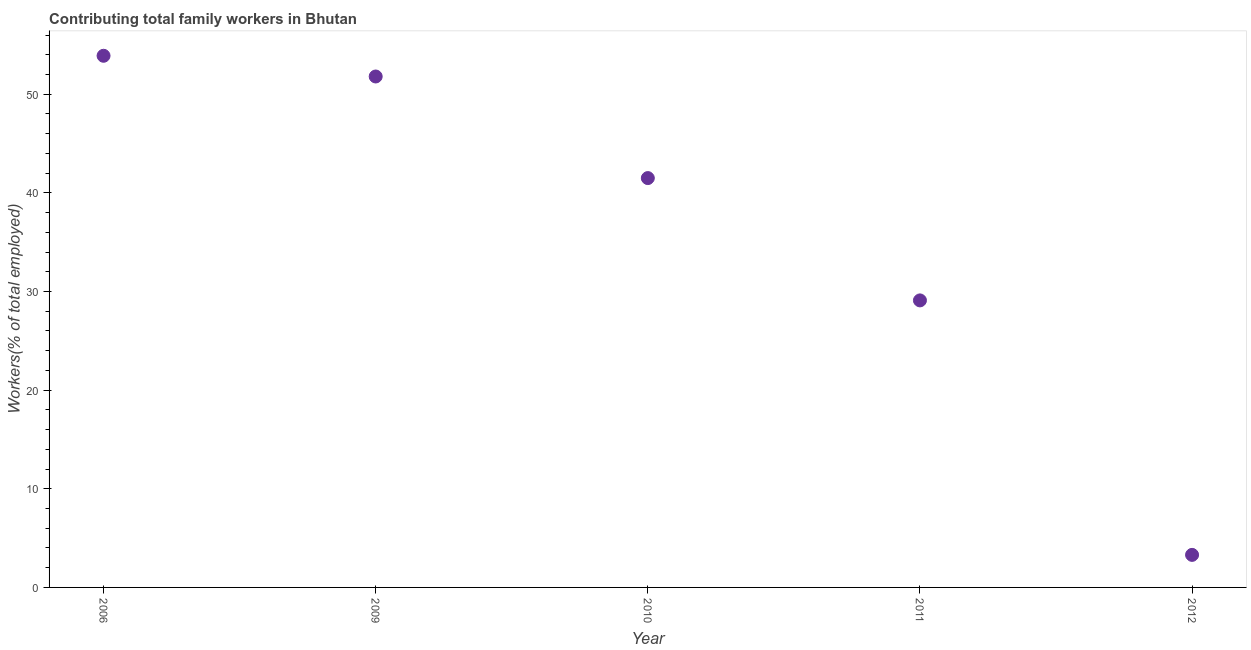What is the contributing family workers in 2012?
Give a very brief answer. 3.3. Across all years, what is the maximum contributing family workers?
Your answer should be compact. 53.9. Across all years, what is the minimum contributing family workers?
Make the answer very short. 3.3. In which year was the contributing family workers maximum?
Your answer should be compact. 2006. In which year was the contributing family workers minimum?
Your answer should be compact. 2012. What is the sum of the contributing family workers?
Make the answer very short. 179.6. What is the difference between the contributing family workers in 2010 and 2012?
Offer a terse response. 38.2. What is the average contributing family workers per year?
Your answer should be compact. 35.92. What is the median contributing family workers?
Your answer should be compact. 41.5. In how many years, is the contributing family workers greater than 6 %?
Keep it short and to the point. 4. What is the ratio of the contributing family workers in 2006 to that in 2009?
Keep it short and to the point. 1.04. Is the contributing family workers in 2006 less than that in 2009?
Keep it short and to the point. No. Is the difference between the contributing family workers in 2009 and 2012 greater than the difference between any two years?
Keep it short and to the point. No. What is the difference between the highest and the second highest contributing family workers?
Keep it short and to the point. 2.1. Is the sum of the contributing family workers in 2006 and 2011 greater than the maximum contributing family workers across all years?
Give a very brief answer. Yes. What is the difference between the highest and the lowest contributing family workers?
Offer a very short reply. 50.6. How many years are there in the graph?
Provide a short and direct response. 5. What is the difference between two consecutive major ticks on the Y-axis?
Keep it short and to the point. 10. Does the graph contain grids?
Make the answer very short. No. What is the title of the graph?
Provide a succinct answer. Contributing total family workers in Bhutan. What is the label or title of the Y-axis?
Offer a very short reply. Workers(% of total employed). What is the Workers(% of total employed) in 2006?
Your response must be concise. 53.9. What is the Workers(% of total employed) in 2009?
Your answer should be compact. 51.8. What is the Workers(% of total employed) in 2010?
Your answer should be compact. 41.5. What is the Workers(% of total employed) in 2011?
Provide a succinct answer. 29.1. What is the Workers(% of total employed) in 2012?
Your answer should be very brief. 3.3. What is the difference between the Workers(% of total employed) in 2006 and 2009?
Provide a succinct answer. 2.1. What is the difference between the Workers(% of total employed) in 2006 and 2011?
Ensure brevity in your answer.  24.8. What is the difference between the Workers(% of total employed) in 2006 and 2012?
Your answer should be compact. 50.6. What is the difference between the Workers(% of total employed) in 2009 and 2011?
Your response must be concise. 22.7. What is the difference between the Workers(% of total employed) in 2009 and 2012?
Provide a succinct answer. 48.5. What is the difference between the Workers(% of total employed) in 2010 and 2011?
Ensure brevity in your answer.  12.4. What is the difference between the Workers(% of total employed) in 2010 and 2012?
Offer a terse response. 38.2. What is the difference between the Workers(% of total employed) in 2011 and 2012?
Your answer should be compact. 25.8. What is the ratio of the Workers(% of total employed) in 2006 to that in 2009?
Ensure brevity in your answer.  1.04. What is the ratio of the Workers(% of total employed) in 2006 to that in 2010?
Provide a succinct answer. 1.3. What is the ratio of the Workers(% of total employed) in 2006 to that in 2011?
Provide a succinct answer. 1.85. What is the ratio of the Workers(% of total employed) in 2006 to that in 2012?
Provide a succinct answer. 16.33. What is the ratio of the Workers(% of total employed) in 2009 to that in 2010?
Ensure brevity in your answer.  1.25. What is the ratio of the Workers(% of total employed) in 2009 to that in 2011?
Keep it short and to the point. 1.78. What is the ratio of the Workers(% of total employed) in 2009 to that in 2012?
Give a very brief answer. 15.7. What is the ratio of the Workers(% of total employed) in 2010 to that in 2011?
Ensure brevity in your answer.  1.43. What is the ratio of the Workers(% of total employed) in 2010 to that in 2012?
Offer a terse response. 12.58. What is the ratio of the Workers(% of total employed) in 2011 to that in 2012?
Your response must be concise. 8.82. 